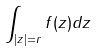<formula> <loc_0><loc_0><loc_500><loc_500>\int _ { | z | = r } f ( z ) d z</formula> 